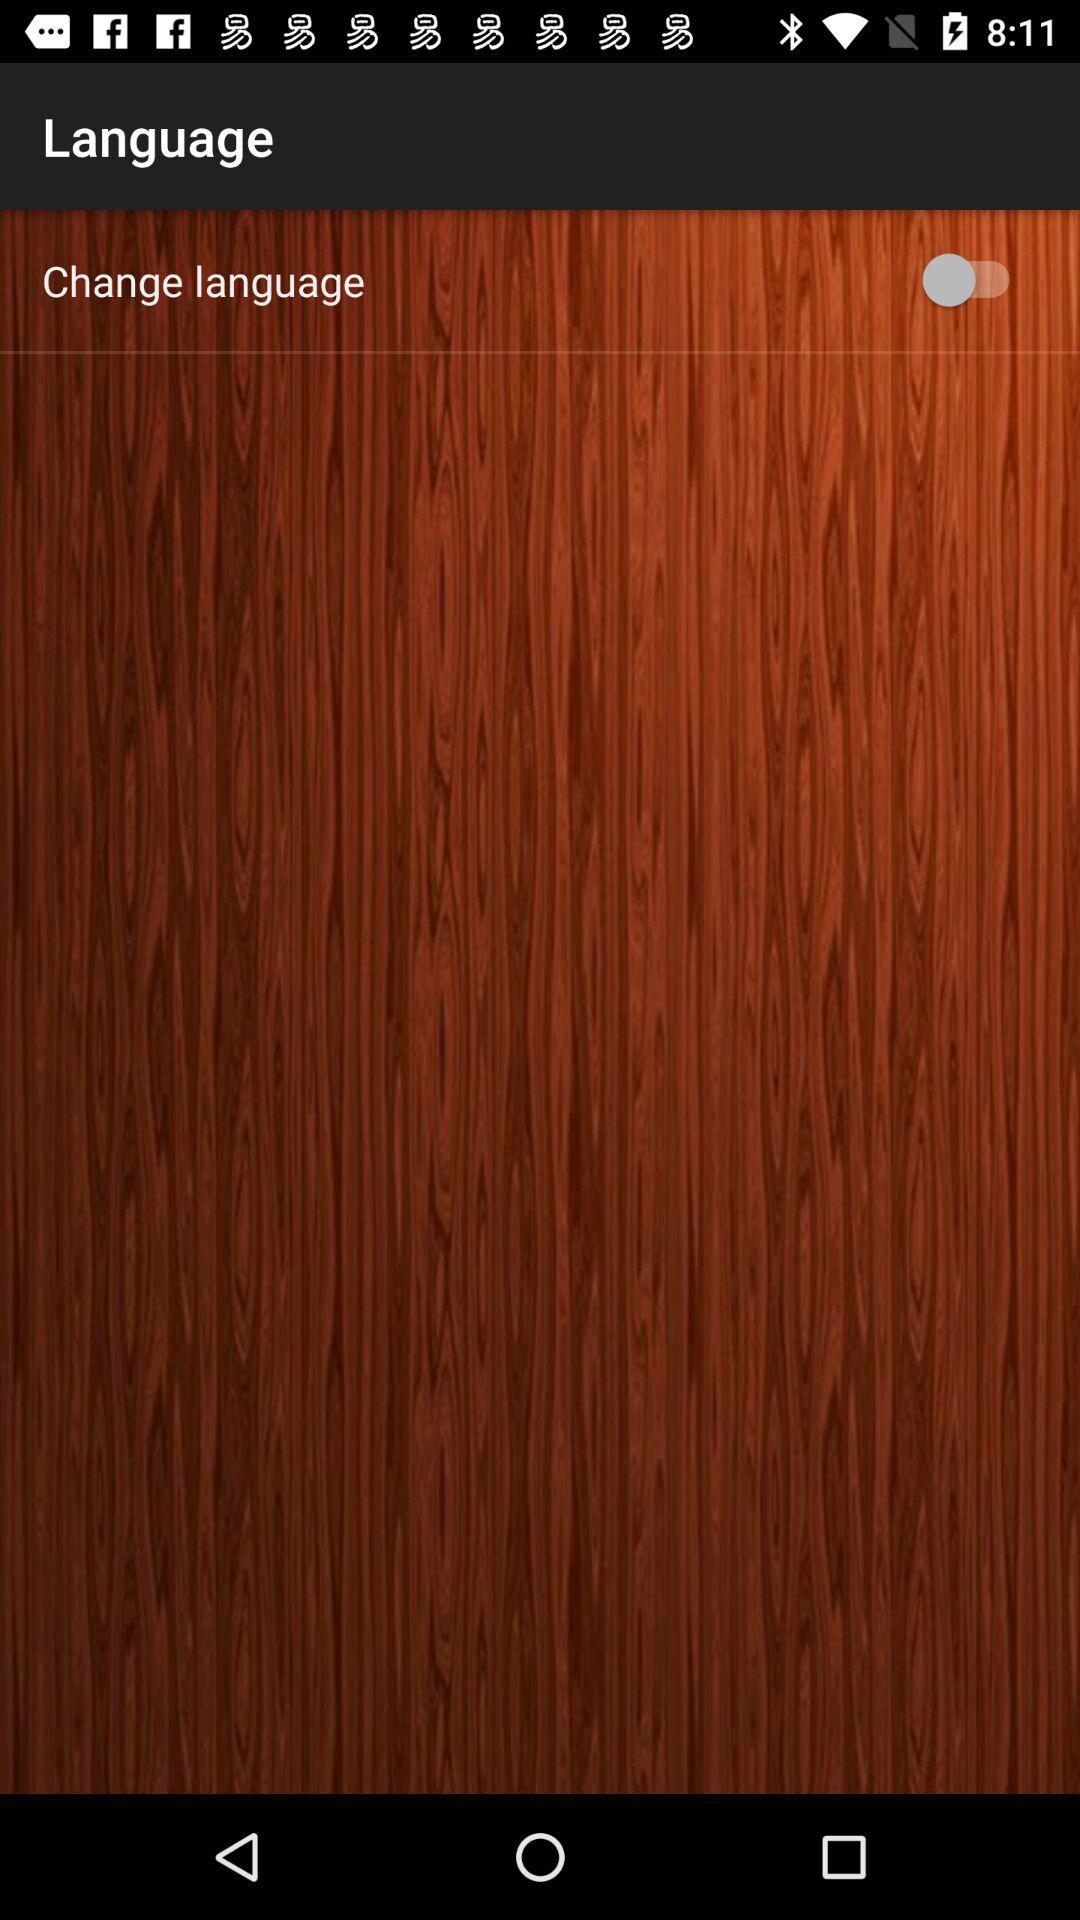What is the current status of the "Change language" setting? The current status is off. 